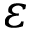<formula> <loc_0><loc_0><loc_500><loc_500>\varepsilon</formula> 